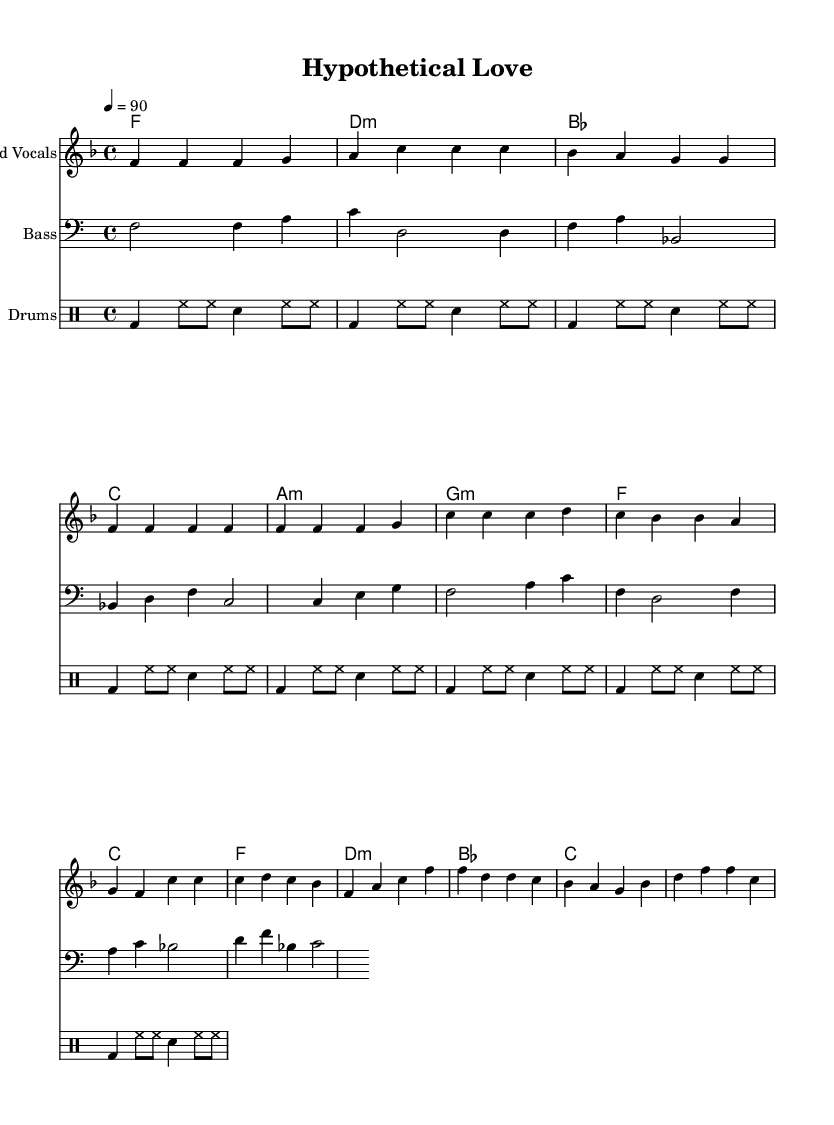What is the key signature of this music? The key signature is identified by looking for the symbols at the beginning of the staff. In this case, there are one flat (B) indicated which confirms that the piece is in F major.
Answer: F major What is the time signature of this music? The time signature is determined by the two numbers shown at the beginning of the piece. Here, the top number is 4 and the bottom number is 4, indicating that there are four beats in each measure and the quarter note gets one beat.
Answer: 4/4 What is the tempo marking of this music? The tempo marking is found at the beginning of the score where it indicates the beats per minute. In this case, it states "4 = 90," meaning that there are 90 quarter note beats in a minute.
Answer: 90 How many verses are present in the lyrics? By analyzing the provided lyric sections in the score, it is clear that the lyrics begin with a "Verse," followed by a "Pre-Chorus," and then a "Chorus." The presence of one verse is indicated.
Answer: 1 What is the pattern of the drum rhythm? The drum rhythm pattern is evident due to the repetitive nature of the symbols used for bass drum and snare. It follows a sequence of bass drum, hi-hat, and snare in a consistent pattern throughout.
Answer: Four measures What metaphor does the chorus of the song use to describe love and research? In the chorus, love is metaphorically compared to the process of research, using terms like "hypothesis" and "testing our connection," which connects the concept of emotional relationships to a scientific approach.
Answer: Research What instrumental role does the bass line serve in this piece? The bass line, noted as a separate staff, provides harmonic foundation and drives the rhythm forward. It supports the melody and adds depth to the overall texture of the song.
Answer: Harmonic foundation 